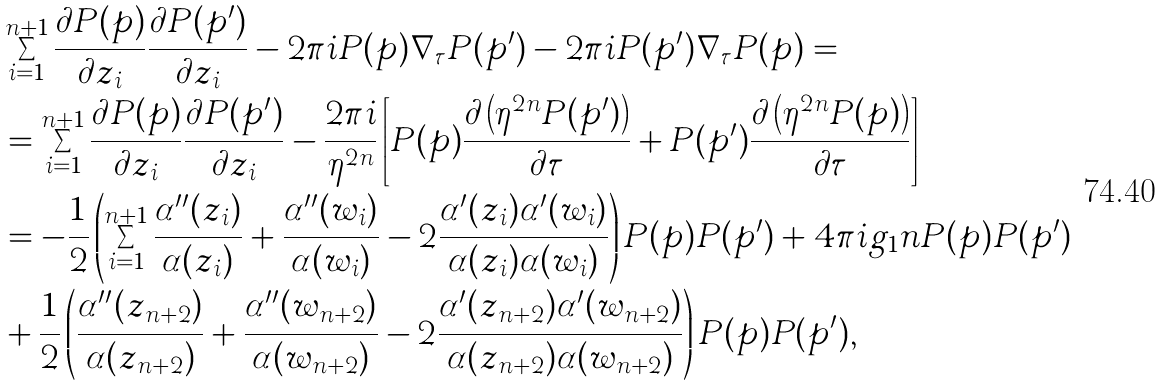<formula> <loc_0><loc_0><loc_500><loc_500>& \sum _ { i = 1 } ^ { n + 1 } \frac { \partial P ( p ) } { \partial z _ { i } } \frac { \partial P ( p ^ { \prime } ) } { \partial z _ { i } } - 2 \pi i P ( p ) \nabla _ { \tau } P ( p ^ { \prime } ) - 2 \pi i P ( p ^ { \prime } ) \nabla _ { \tau } P ( p ) = \\ & = \sum _ { i = 1 } ^ { n + 1 } \frac { \partial P ( p ) } { \partial z _ { i } } \frac { \partial P ( p ^ { \prime } ) } { \partial z _ { i } } - \frac { 2 \pi i } { \eta ^ { 2 n } } \left [ P ( p ) \frac { \partial \left ( \eta ^ { 2 n } P ( p ^ { \prime } ) \right ) } { \partial \tau } + P ( p ^ { \prime } ) \frac { \partial \left ( \eta ^ { 2 n } P ( p ) \right ) } { \partial \tau } \right ] \\ & = - \frac { 1 } { 2 } \left ( \sum _ { i = 1 } ^ { n + 1 } \frac { \alpha ^ { \prime \prime } ( z _ { i } ) } { \alpha ( z _ { i } ) } + \frac { \alpha ^ { \prime \prime } ( w _ { i } ) } { \alpha ( w _ { i } ) } - 2 \frac { \alpha ^ { \prime } ( z _ { i } ) \alpha ^ { \prime } ( w _ { i } ) } { \alpha ( z _ { i } ) \alpha ( w _ { i } ) } \right ) P ( p ) P ( p ^ { \prime } ) + 4 \pi i g _ { 1 } n P ( p ) P ( p ^ { \prime } ) \\ & + \frac { 1 } { 2 } \left ( \frac { \alpha ^ { \prime \prime } ( z _ { n + 2 } ) } { \alpha ( z _ { n + 2 } ) } + \frac { \alpha ^ { \prime \prime } ( w _ { n + 2 } ) } { \alpha ( w _ { n + 2 } ) } - 2 \frac { \alpha ^ { \prime } ( z _ { n + 2 } ) \alpha ^ { \prime } ( w _ { n + 2 } ) } { \alpha ( z _ { n + 2 } ) \alpha ( w _ { n + 2 } ) } \right ) P ( p ) P ( p ^ { \prime } ) , \\</formula> 